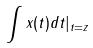<formula> <loc_0><loc_0><loc_500><loc_500>\int x ( t ) d t | _ { t = z }</formula> 